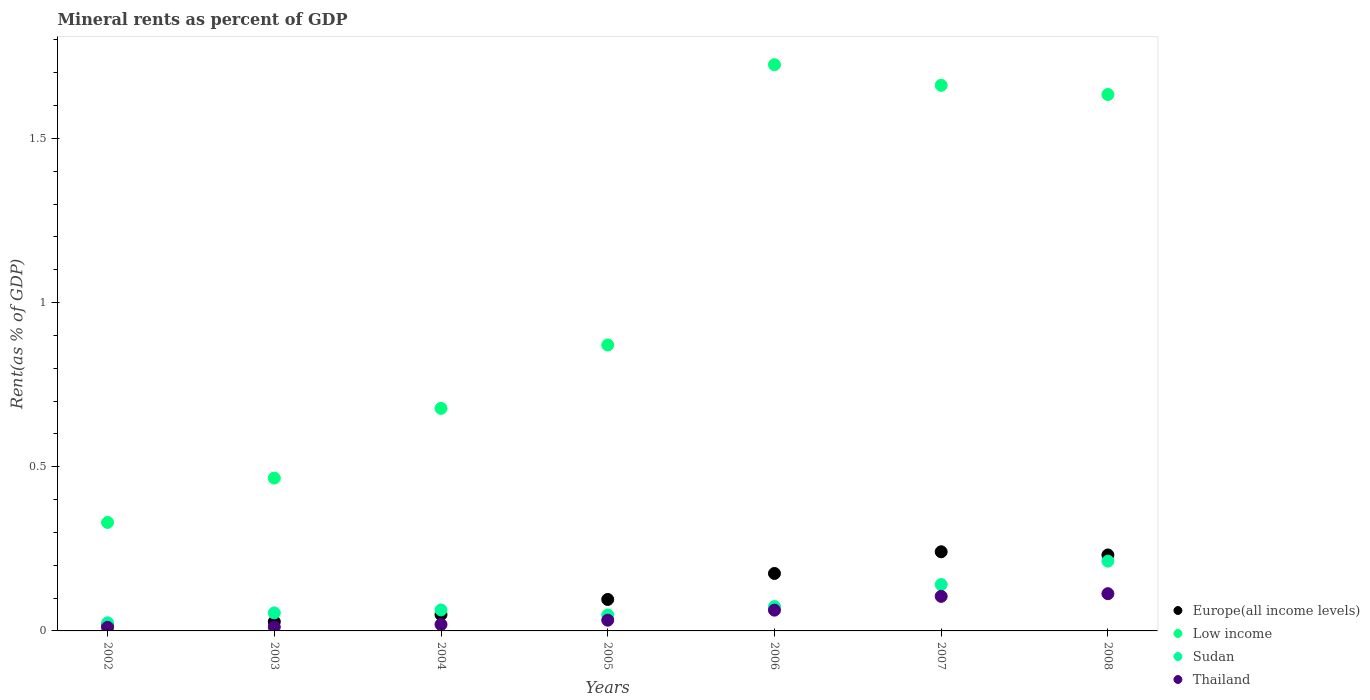How many different coloured dotlines are there?
Offer a very short reply. 4. Is the number of dotlines equal to the number of legend labels?
Keep it short and to the point. Yes. What is the mineral rent in Thailand in 2008?
Provide a succinct answer. 0.11. Across all years, what is the maximum mineral rent in Low income?
Give a very brief answer. 1.72. Across all years, what is the minimum mineral rent in Europe(all income levels)?
Ensure brevity in your answer.  0.02. In which year was the mineral rent in Thailand maximum?
Provide a short and direct response. 2008. In which year was the mineral rent in Europe(all income levels) minimum?
Your response must be concise. 2002. What is the total mineral rent in Europe(all income levels) in the graph?
Provide a short and direct response. 0.84. What is the difference between the mineral rent in Europe(all income levels) in 2003 and that in 2008?
Keep it short and to the point. -0.2. What is the difference between the mineral rent in Europe(all income levels) in 2006 and the mineral rent in Low income in 2004?
Provide a short and direct response. -0.5. What is the average mineral rent in Low income per year?
Keep it short and to the point. 1.05. In the year 2008, what is the difference between the mineral rent in Sudan and mineral rent in Thailand?
Offer a very short reply. 0.1. What is the ratio of the mineral rent in Thailand in 2007 to that in 2008?
Give a very brief answer. 0.93. Is the mineral rent in Sudan in 2003 less than that in 2004?
Ensure brevity in your answer.  Yes. Is the difference between the mineral rent in Sudan in 2003 and 2008 greater than the difference between the mineral rent in Thailand in 2003 and 2008?
Your response must be concise. No. What is the difference between the highest and the second highest mineral rent in Sudan?
Provide a short and direct response. 0.07. What is the difference between the highest and the lowest mineral rent in Low income?
Keep it short and to the point. 1.39. Is the sum of the mineral rent in Sudan in 2002 and 2006 greater than the maximum mineral rent in Europe(all income levels) across all years?
Ensure brevity in your answer.  No. Is it the case that in every year, the sum of the mineral rent in Low income and mineral rent in Europe(all income levels)  is greater than the sum of mineral rent in Thailand and mineral rent in Sudan?
Provide a short and direct response. Yes. Is it the case that in every year, the sum of the mineral rent in Low income and mineral rent in Europe(all income levels)  is greater than the mineral rent in Thailand?
Make the answer very short. Yes. Does the mineral rent in Low income monotonically increase over the years?
Give a very brief answer. No. How many dotlines are there?
Provide a short and direct response. 4. How many years are there in the graph?
Your answer should be very brief. 7. Where does the legend appear in the graph?
Ensure brevity in your answer.  Bottom right. How many legend labels are there?
Offer a very short reply. 4. How are the legend labels stacked?
Offer a very short reply. Vertical. What is the title of the graph?
Give a very brief answer. Mineral rents as percent of GDP. What is the label or title of the Y-axis?
Give a very brief answer. Rent(as % of GDP). What is the Rent(as % of GDP) of Europe(all income levels) in 2002?
Give a very brief answer. 0.02. What is the Rent(as % of GDP) in Low income in 2002?
Keep it short and to the point. 0.33. What is the Rent(as % of GDP) of Sudan in 2002?
Offer a terse response. 0.02. What is the Rent(as % of GDP) in Thailand in 2002?
Provide a short and direct response. 0.01. What is the Rent(as % of GDP) in Europe(all income levels) in 2003?
Give a very brief answer. 0.03. What is the Rent(as % of GDP) in Low income in 2003?
Ensure brevity in your answer.  0.47. What is the Rent(as % of GDP) of Sudan in 2003?
Offer a very short reply. 0.05. What is the Rent(as % of GDP) in Thailand in 2003?
Your response must be concise. 0.01. What is the Rent(as % of GDP) of Europe(all income levels) in 2004?
Offer a terse response. 0.05. What is the Rent(as % of GDP) of Low income in 2004?
Provide a short and direct response. 0.68. What is the Rent(as % of GDP) of Sudan in 2004?
Provide a short and direct response. 0.06. What is the Rent(as % of GDP) in Thailand in 2004?
Your answer should be compact. 0.02. What is the Rent(as % of GDP) in Europe(all income levels) in 2005?
Provide a succinct answer. 0.1. What is the Rent(as % of GDP) of Low income in 2005?
Offer a terse response. 0.87. What is the Rent(as % of GDP) of Sudan in 2005?
Provide a short and direct response. 0.05. What is the Rent(as % of GDP) of Thailand in 2005?
Keep it short and to the point. 0.03. What is the Rent(as % of GDP) in Europe(all income levels) in 2006?
Give a very brief answer. 0.18. What is the Rent(as % of GDP) of Low income in 2006?
Your answer should be compact. 1.72. What is the Rent(as % of GDP) of Sudan in 2006?
Your response must be concise. 0.07. What is the Rent(as % of GDP) of Thailand in 2006?
Your answer should be compact. 0.06. What is the Rent(as % of GDP) of Europe(all income levels) in 2007?
Offer a terse response. 0.24. What is the Rent(as % of GDP) of Low income in 2007?
Your answer should be compact. 1.66. What is the Rent(as % of GDP) of Sudan in 2007?
Make the answer very short. 0.14. What is the Rent(as % of GDP) of Thailand in 2007?
Make the answer very short. 0.11. What is the Rent(as % of GDP) in Europe(all income levels) in 2008?
Offer a terse response. 0.23. What is the Rent(as % of GDP) in Low income in 2008?
Make the answer very short. 1.63. What is the Rent(as % of GDP) in Sudan in 2008?
Keep it short and to the point. 0.21. What is the Rent(as % of GDP) in Thailand in 2008?
Make the answer very short. 0.11. Across all years, what is the maximum Rent(as % of GDP) of Europe(all income levels)?
Provide a short and direct response. 0.24. Across all years, what is the maximum Rent(as % of GDP) in Low income?
Give a very brief answer. 1.72. Across all years, what is the maximum Rent(as % of GDP) of Sudan?
Provide a short and direct response. 0.21. Across all years, what is the maximum Rent(as % of GDP) of Thailand?
Your answer should be very brief. 0.11. Across all years, what is the minimum Rent(as % of GDP) of Europe(all income levels)?
Provide a succinct answer. 0.02. Across all years, what is the minimum Rent(as % of GDP) of Low income?
Offer a terse response. 0.33. Across all years, what is the minimum Rent(as % of GDP) of Sudan?
Offer a terse response. 0.02. Across all years, what is the minimum Rent(as % of GDP) in Thailand?
Your answer should be very brief. 0.01. What is the total Rent(as % of GDP) in Europe(all income levels) in the graph?
Your answer should be compact. 0.84. What is the total Rent(as % of GDP) of Low income in the graph?
Provide a succinct answer. 7.36. What is the total Rent(as % of GDP) in Sudan in the graph?
Offer a very short reply. 0.62. What is the total Rent(as % of GDP) in Thailand in the graph?
Offer a terse response. 0.36. What is the difference between the Rent(as % of GDP) in Europe(all income levels) in 2002 and that in 2003?
Give a very brief answer. -0.01. What is the difference between the Rent(as % of GDP) of Low income in 2002 and that in 2003?
Offer a terse response. -0.14. What is the difference between the Rent(as % of GDP) in Sudan in 2002 and that in 2003?
Provide a short and direct response. -0.03. What is the difference between the Rent(as % of GDP) in Thailand in 2002 and that in 2003?
Your answer should be very brief. -0. What is the difference between the Rent(as % of GDP) of Europe(all income levels) in 2002 and that in 2004?
Offer a very short reply. -0.03. What is the difference between the Rent(as % of GDP) of Low income in 2002 and that in 2004?
Give a very brief answer. -0.35. What is the difference between the Rent(as % of GDP) of Sudan in 2002 and that in 2004?
Your answer should be very brief. -0.04. What is the difference between the Rent(as % of GDP) of Thailand in 2002 and that in 2004?
Offer a very short reply. -0.01. What is the difference between the Rent(as % of GDP) in Europe(all income levels) in 2002 and that in 2005?
Offer a terse response. -0.08. What is the difference between the Rent(as % of GDP) in Low income in 2002 and that in 2005?
Ensure brevity in your answer.  -0.54. What is the difference between the Rent(as % of GDP) of Sudan in 2002 and that in 2005?
Offer a very short reply. -0.02. What is the difference between the Rent(as % of GDP) in Thailand in 2002 and that in 2005?
Your answer should be very brief. -0.02. What is the difference between the Rent(as % of GDP) of Europe(all income levels) in 2002 and that in 2006?
Offer a very short reply. -0.16. What is the difference between the Rent(as % of GDP) of Low income in 2002 and that in 2006?
Provide a succinct answer. -1.39. What is the difference between the Rent(as % of GDP) in Sudan in 2002 and that in 2006?
Offer a very short reply. -0.05. What is the difference between the Rent(as % of GDP) in Thailand in 2002 and that in 2006?
Keep it short and to the point. -0.05. What is the difference between the Rent(as % of GDP) in Europe(all income levels) in 2002 and that in 2007?
Keep it short and to the point. -0.22. What is the difference between the Rent(as % of GDP) of Low income in 2002 and that in 2007?
Offer a very short reply. -1.33. What is the difference between the Rent(as % of GDP) of Sudan in 2002 and that in 2007?
Provide a succinct answer. -0.12. What is the difference between the Rent(as % of GDP) of Thailand in 2002 and that in 2007?
Ensure brevity in your answer.  -0.09. What is the difference between the Rent(as % of GDP) in Europe(all income levels) in 2002 and that in 2008?
Your answer should be compact. -0.21. What is the difference between the Rent(as % of GDP) of Low income in 2002 and that in 2008?
Offer a very short reply. -1.3. What is the difference between the Rent(as % of GDP) in Sudan in 2002 and that in 2008?
Your answer should be compact. -0.19. What is the difference between the Rent(as % of GDP) of Thailand in 2002 and that in 2008?
Provide a succinct answer. -0.1. What is the difference between the Rent(as % of GDP) in Europe(all income levels) in 2003 and that in 2004?
Keep it short and to the point. -0.02. What is the difference between the Rent(as % of GDP) of Low income in 2003 and that in 2004?
Offer a very short reply. -0.21. What is the difference between the Rent(as % of GDP) in Sudan in 2003 and that in 2004?
Provide a succinct answer. -0.01. What is the difference between the Rent(as % of GDP) of Thailand in 2003 and that in 2004?
Ensure brevity in your answer.  -0.01. What is the difference between the Rent(as % of GDP) in Europe(all income levels) in 2003 and that in 2005?
Your answer should be compact. -0.07. What is the difference between the Rent(as % of GDP) in Low income in 2003 and that in 2005?
Provide a succinct answer. -0.41. What is the difference between the Rent(as % of GDP) of Sudan in 2003 and that in 2005?
Ensure brevity in your answer.  0.01. What is the difference between the Rent(as % of GDP) in Thailand in 2003 and that in 2005?
Your response must be concise. -0.02. What is the difference between the Rent(as % of GDP) of Europe(all income levels) in 2003 and that in 2006?
Give a very brief answer. -0.15. What is the difference between the Rent(as % of GDP) of Low income in 2003 and that in 2006?
Keep it short and to the point. -1.26. What is the difference between the Rent(as % of GDP) in Sudan in 2003 and that in 2006?
Your answer should be compact. -0.02. What is the difference between the Rent(as % of GDP) of Thailand in 2003 and that in 2006?
Offer a very short reply. -0.05. What is the difference between the Rent(as % of GDP) in Europe(all income levels) in 2003 and that in 2007?
Offer a very short reply. -0.21. What is the difference between the Rent(as % of GDP) in Low income in 2003 and that in 2007?
Provide a succinct answer. -1.2. What is the difference between the Rent(as % of GDP) in Sudan in 2003 and that in 2007?
Ensure brevity in your answer.  -0.09. What is the difference between the Rent(as % of GDP) of Thailand in 2003 and that in 2007?
Provide a succinct answer. -0.09. What is the difference between the Rent(as % of GDP) of Europe(all income levels) in 2003 and that in 2008?
Provide a succinct answer. -0.2. What is the difference between the Rent(as % of GDP) of Low income in 2003 and that in 2008?
Offer a terse response. -1.17. What is the difference between the Rent(as % of GDP) in Sudan in 2003 and that in 2008?
Keep it short and to the point. -0.16. What is the difference between the Rent(as % of GDP) in Thailand in 2003 and that in 2008?
Provide a succinct answer. -0.1. What is the difference between the Rent(as % of GDP) in Europe(all income levels) in 2004 and that in 2005?
Your answer should be very brief. -0.05. What is the difference between the Rent(as % of GDP) of Low income in 2004 and that in 2005?
Your answer should be compact. -0.19. What is the difference between the Rent(as % of GDP) in Sudan in 2004 and that in 2005?
Provide a short and direct response. 0.02. What is the difference between the Rent(as % of GDP) of Thailand in 2004 and that in 2005?
Offer a terse response. -0.01. What is the difference between the Rent(as % of GDP) of Europe(all income levels) in 2004 and that in 2006?
Your response must be concise. -0.13. What is the difference between the Rent(as % of GDP) of Low income in 2004 and that in 2006?
Make the answer very short. -1.05. What is the difference between the Rent(as % of GDP) in Sudan in 2004 and that in 2006?
Your response must be concise. -0.01. What is the difference between the Rent(as % of GDP) in Thailand in 2004 and that in 2006?
Keep it short and to the point. -0.04. What is the difference between the Rent(as % of GDP) in Europe(all income levels) in 2004 and that in 2007?
Provide a succinct answer. -0.19. What is the difference between the Rent(as % of GDP) of Low income in 2004 and that in 2007?
Ensure brevity in your answer.  -0.98. What is the difference between the Rent(as % of GDP) in Sudan in 2004 and that in 2007?
Give a very brief answer. -0.08. What is the difference between the Rent(as % of GDP) of Thailand in 2004 and that in 2007?
Keep it short and to the point. -0.09. What is the difference between the Rent(as % of GDP) in Europe(all income levels) in 2004 and that in 2008?
Offer a very short reply. -0.18. What is the difference between the Rent(as % of GDP) of Low income in 2004 and that in 2008?
Offer a very short reply. -0.96. What is the difference between the Rent(as % of GDP) in Sudan in 2004 and that in 2008?
Offer a terse response. -0.15. What is the difference between the Rent(as % of GDP) of Thailand in 2004 and that in 2008?
Offer a terse response. -0.09. What is the difference between the Rent(as % of GDP) of Europe(all income levels) in 2005 and that in 2006?
Give a very brief answer. -0.08. What is the difference between the Rent(as % of GDP) in Low income in 2005 and that in 2006?
Your response must be concise. -0.85. What is the difference between the Rent(as % of GDP) in Sudan in 2005 and that in 2006?
Your answer should be very brief. -0.03. What is the difference between the Rent(as % of GDP) of Thailand in 2005 and that in 2006?
Keep it short and to the point. -0.03. What is the difference between the Rent(as % of GDP) in Europe(all income levels) in 2005 and that in 2007?
Your answer should be compact. -0.15. What is the difference between the Rent(as % of GDP) of Low income in 2005 and that in 2007?
Offer a very short reply. -0.79. What is the difference between the Rent(as % of GDP) of Sudan in 2005 and that in 2007?
Your response must be concise. -0.09. What is the difference between the Rent(as % of GDP) of Thailand in 2005 and that in 2007?
Make the answer very short. -0.07. What is the difference between the Rent(as % of GDP) of Europe(all income levels) in 2005 and that in 2008?
Offer a terse response. -0.14. What is the difference between the Rent(as % of GDP) of Low income in 2005 and that in 2008?
Provide a short and direct response. -0.76. What is the difference between the Rent(as % of GDP) of Sudan in 2005 and that in 2008?
Provide a short and direct response. -0.16. What is the difference between the Rent(as % of GDP) of Thailand in 2005 and that in 2008?
Your response must be concise. -0.08. What is the difference between the Rent(as % of GDP) of Europe(all income levels) in 2006 and that in 2007?
Your response must be concise. -0.07. What is the difference between the Rent(as % of GDP) of Low income in 2006 and that in 2007?
Provide a short and direct response. 0.06. What is the difference between the Rent(as % of GDP) in Sudan in 2006 and that in 2007?
Provide a succinct answer. -0.07. What is the difference between the Rent(as % of GDP) of Thailand in 2006 and that in 2007?
Offer a terse response. -0.04. What is the difference between the Rent(as % of GDP) in Europe(all income levels) in 2006 and that in 2008?
Ensure brevity in your answer.  -0.06. What is the difference between the Rent(as % of GDP) of Low income in 2006 and that in 2008?
Offer a very short reply. 0.09. What is the difference between the Rent(as % of GDP) of Sudan in 2006 and that in 2008?
Offer a very short reply. -0.14. What is the difference between the Rent(as % of GDP) of Thailand in 2006 and that in 2008?
Your response must be concise. -0.05. What is the difference between the Rent(as % of GDP) in Europe(all income levels) in 2007 and that in 2008?
Give a very brief answer. 0.01. What is the difference between the Rent(as % of GDP) of Low income in 2007 and that in 2008?
Make the answer very short. 0.03. What is the difference between the Rent(as % of GDP) in Sudan in 2007 and that in 2008?
Offer a terse response. -0.07. What is the difference between the Rent(as % of GDP) of Thailand in 2007 and that in 2008?
Offer a terse response. -0.01. What is the difference between the Rent(as % of GDP) of Europe(all income levels) in 2002 and the Rent(as % of GDP) of Low income in 2003?
Provide a short and direct response. -0.45. What is the difference between the Rent(as % of GDP) in Europe(all income levels) in 2002 and the Rent(as % of GDP) in Sudan in 2003?
Make the answer very short. -0.04. What is the difference between the Rent(as % of GDP) of Europe(all income levels) in 2002 and the Rent(as % of GDP) of Thailand in 2003?
Offer a terse response. 0.01. What is the difference between the Rent(as % of GDP) of Low income in 2002 and the Rent(as % of GDP) of Sudan in 2003?
Provide a short and direct response. 0.28. What is the difference between the Rent(as % of GDP) in Low income in 2002 and the Rent(as % of GDP) in Thailand in 2003?
Give a very brief answer. 0.32. What is the difference between the Rent(as % of GDP) in Sudan in 2002 and the Rent(as % of GDP) in Thailand in 2003?
Offer a very short reply. 0.01. What is the difference between the Rent(as % of GDP) of Europe(all income levels) in 2002 and the Rent(as % of GDP) of Low income in 2004?
Offer a very short reply. -0.66. What is the difference between the Rent(as % of GDP) of Europe(all income levels) in 2002 and the Rent(as % of GDP) of Sudan in 2004?
Your answer should be compact. -0.05. What is the difference between the Rent(as % of GDP) of Europe(all income levels) in 2002 and the Rent(as % of GDP) of Thailand in 2004?
Offer a terse response. -0. What is the difference between the Rent(as % of GDP) in Low income in 2002 and the Rent(as % of GDP) in Sudan in 2004?
Your answer should be compact. 0.27. What is the difference between the Rent(as % of GDP) of Low income in 2002 and the Rent(as % of GDP) of Thailand in 2004?
Keep it short and to the point. 0.31. What is the difference between the Rent(as % of GDP) in Sudan in 2002 and the Rent(as % of GDP) in Thailand in 2004?
Offer a very short reply. 0.01. What is the difference between the Rent(as % of GDP) in Europe(all income levels) in 2002 and the Rent(as % of GDP) in Low income in 2005?
Provide a succinct answer. -0.85. What is the difference between the Rent(as % of GDP) of Europe(all income levels) in 2002 and the Rent(as % of GDP) of Sudan in 2005?
Your answer should be compact. -0.03. What is the difference between the Rent(as % of GDP) in Europe(all income levels) in 2002 and the Rent(as % of GDP) in Thailand in 2005?
Keep it short and to the point. -0.01. What is the difference between the Rent(as % of GDP) in Low income in 2002 and the Rent(as % of GDP) in Sudan in 2005?
Keep it short and to the point. 0.28. What is the difference between the Rent(as % of GDP) of Low income in 2002 and the Rent(as % of GDP) of Thailand in 2005?
Give a very brief answer. 0.3. What is the difference between the Rent(as % of GDP) of Sudan in 2002 and the Rent(as % of GDP) of Thailand in 2005?
Ensure brevity in your answer.  -0.01. What is the difference between the Rent(as % of GDP) of Europe(all income levels) in 2002 and the Rent(as % of GDP) of Low income in 2006?
Your answer should be compact. -1.71. What is the difference between the Rent(as % of GDP) in Europe(all income levels) in 2002 and the Rent(as % of GDP) in Sudan in 2006?
Your answer should be very brief. -0.06. What is the difference between the Rent(as % of GDP) in Europe(all income levels) in 2002 and the Rent(as % of GDP) in Thailand in 2006?
Offer a very short reply. -0.05. What is the difference between the Rent(as % of GDP) of Low income in 2002 and the Rent(as % of GDP) of Sudan in 2006?
Your response must be concise. 0.26. What is the difference between the Rent(as % of GDP) of Low income in 2002 and the Rent(as % of GDP) of Thailand in 2006?
Provide a short and direct response. 0.27. What is the difference between the Rent(as % of GDP) in Sudan in 2002 and the Rent(as % of GDP) in Thailand in 2006?
Your answer should be compact. -0.04. What is the difference between the Rent(as % of GDP) of Europe(all income levels) in 2002 and the Rent(as % of GDP) of Low income in 2007?
Keep it short and to the point. -1.64. What is the difference between the Rent(as % of GDP) of Europe(all income levels) in 2002 and the Rent(as % of GDP) of Sudan in 2007?
Offer a terse response. -0.12. What is the difference between the Rent(as % of GDP) of Europe(all income levels) in 2002 and the Rent(as % of GDP) of Thailand in 2007?
Offer a very short reply. -0.09. What is the difference between the Rent(as % of GDP) in Low income in 2002 and the Rent(as % of GDP) in Sudan in 2007?
Offer a terse response. 0.19. What is the difference between the Rent(as % of GDP) in Low income in 2002 and the Rent(as % of GDP) in Thailand in 2007?
Provide a short and direct response. 0.23. What is the difference between the Rent(as % of GDP) in Sudan in 2002 and the Rent(as % of GDP) in Thailand in 2007?
Offer a very short reply. -0.08. What is the difference between the Rent(as % of GDP) of Europe(all income levels) in 2002 and the Rent(as % of GDP) of Low income in 2008?
Ensure brevity in your answer.  -1.62. What is the difference between the Rent(as % of GDP) of Europe(all income levels) in 2002 and the Rent(as % of GDP) of Sudan in 2008?
Give a very brief answer. -0.19. What is the difference between the Rent(as % of GDP) in Europe(all income levels) in 2002 and the Rent(as % of GDP) in Thailand in 2008?
Ensure brevity in your answer.  -0.1. What is the difference between the Rent(as % of GDP) in Low income in 2002 and the Rent(as % of GDP) in Sudan in 2008?
Ensure brevity in your answer.  0.12. What is the difference between the Rent(as % of GDP) in Low income in 2002 and the Rent(as % of GDP) in Thailand in 2008?
Give a very brief answer. 0.22. What is the difference between the Rent(as % of GDP) in Sudan in 2002 and the Rent(as % of GDP) in Thailand in 2008?
Keep it short and to the point. -0.09. What is the difference between the Rent(as % of GDP) in Europe(all income levels) in 2003 and the Rent(as % of GDP) in Low income in 2004?
Provide a succinct answer. -0.65. What is the difference between the Rent(as % of GDP) in Europe(all income levels) in 2003 and the Rent(as % of GDP) in Sudan in 2004?
Provide a short and direct response. -0.04. What is the difference between the Rent(as % of GDP) of Europe(all income levels) in 2003 and the Rent(as % of GDP) of Thailand in 2004?
Your answer should be very brief. 0.01. What is the difference between the Rent(as % of GDP) of Low income in 2003 and the Rent(as % of GDP) of Sudan in 2004?
Offer a very short reply. 0.4. What is the difference between the Rent(as % of GDP) of Low income in 2003 and the Rent(as % of GDP) of Thailand in 2004?
Your answer should be very brief. 0.45. What is the difference between the Rent(as % of GDP) of Sudan in 2003 and the Rent(as % of GDP) of Thailand in 2004?
Keep it short and to the point. 0.04. What is the difference between the Rent(as % of GDP) in Europe(all income levels) in 2003 and the Rent(as % of GDP) in Low income in 2005?
Your answer should be compact. -0.84. What is the difference between the Rent(as % of GDP) of Europe(all income levels) in 2003 and the Rent(as % of GDP) of Sudan in 2005?
Ensure brevity in your answer.  -0.02. What is the difference between the Rent(as % of GDP) of Europe(all income levels) in 2003 and the Rent(as % of GDP) of Thailand in 2005?
Your response must be concise. -0. What is the difference between the Rent(as % of GDP) of Low income in 2003 and the Rent(as % of GDP) of Sudan in 2005?
Make the answer very short. 0.42. What is the difference between the Rent(as % of GDP) in Low income in 2003 and the Rent(as % of GDP) in Thailand in 2005?
Keep it short and to the point. 0.43. What is the difference between the Rent(as % of GDP) in Sudan in 2003 and the Rent(as % of GDP) in Thailand in 2005?
Provide a short and direct response. 0.02. What is the difference between the Rent(as % of GDP) of Europe(all income levels) in 2003 and the Rent(as % of GDP) of Low income in 2006?
Your answer should be compact. -1.7. What is the difference between the Rent(as % of GDP) of Europe(all income levels) in 2003 and the Rent(as % of GDP) of Sudan in 2006?
Provide a short and direct response. -0.05. What is the difference between the Rent(as % of GDP) of Europe(all income levels) in 2003 and the Rent(as % of GDP) of Thailand in 2006?
Provide a succinct answer. -0.04. What is the difference between the Rent(as % of GDP) of Low income in 2003 and the Rent(as % of GDP) of Sudan in 2006?
Give a very brief answer. 0.39. What is the difference between the Rent(as % of GDP) of Low income in 2003 and the Rent(as % of GDP) of Thailand in 2006?
Provide a succinct answer. 0.4. What is the difference between the Rent(as % of GDP) in Sudan in 2003 and the Rent(as % of GDP) in Thailand in 2006?
Offer a terse response. -0.01. What is the difference between the Rent(as % of GDP) in Europe(all income levels) in 2003 and the Rent(as % of GDP) in Low income in 2007?
Make the answer very short. -1.63. What is the difference between the Rent(as % of GDP) of Europe(all income levels) in 2003 and the Rent(as % of GDP) of Sudan in 2007?
Your answer should be compact. -0.11. What is the difference between the Rent(as % of GDP) of Europe(all income levels) in 2003 and the Rent(as % of GDP) of Thailand in 2007?
Provide a short and direct response. -0.08. What is the difference between the Rent(as % of GDP) in Low income in 2003 and the Rent(as % of GDP) in Sudan in 2007?
Offer a very short reply. 0.32. What is the difference between the Rent(as % of GDP) in Low income in 2003 and the Rent(as % of GDP) in Thailand in 2007?
Make the answer very short. 0.36. What is the difference between the Rent(as % of GDP) of Sudan in 2003 and the Rent(as % of GDP) of Thailand in 2007?
Your answer should be very brief. -0.05. What is the difference between the Rent(as % of GDP) in Europe(all income levels) in 2003 and the Rent(as % of GDP) in Low income in 2008?
Your response must be concise. -1.61. What is the difference between the Rent(as % of GDP) in Europe(all income levels) in 2003 and the Rent(as % of GDP) in Sudan in 2008?
Ensure brevity in your answer.  -0.18. What is the difference between the Rent(as % of GDP) in Europe(all income levels) in 2003 and the Rent(as % of GDP) in Thailand in 2008?
Your response must be concise. -0.09. What is the difference between the Rent(as % of GDP) in Low income in 2003 and the Rent(as % of GDP) in Sudan in 2008?
Offer a very short reply. 0.25. What is the difference between the Rent(as % of GDP) in Low income in 2003 and the Rent(as % of GDP) in Thailand in 2008?
Give a very brief answer. 0.35. What is the difference between the Rent(as % of GDP) in Sudan in 2003 and the Rent(as % of GDP) in Thailand in 2008?
Provide a succinct answer. -0.06. What is the difference between the Rent(as % of GDP) in Europe(all income levels) in 2004 and the Rent(as % of GDP) in Low income in 2005?
Your answer should be compact. -0.82. What is the difference between the Rent(as % of GDP) in Europe(all income levels) in 2004 and the Rent(as % of GDP) in Sudan in 2005?
Provide a succinct answer. 0. What is the difference between the Rent(as % of GDP) of Europe(all income levels) in 2004 and the Rent(as % of GDP) of Thailand in 2005?
Provide a short and direct response. 0.02. What is the difference between the Rent(as % of GDP) in Low income in 2004 and the Rent(as % of GDP) in Sudan in 2005?
Provide a short and direct response. 0.63. What is the difference between the Rent(as % of GDP) in Low income in 2004 and the Rent(as % of GDP) in Thailand in 2005?
Your response must be concise. 0.65. What is the difference between the Rent(as % of GDP) in Sudan in 2004 and the Rent(as % of GDP) in Thailand in 2005?
Make the answer very short. 0.03. What is the difference between the Rent(as % of GDP) of Europe(all income levels) in 2004 and the Rent(as % of GDP) of Low income in 2006?
Ensure brevity in your answer.  -1.67. What is the difference between the Rent(as % of GDP) in Europe(all income levels) in 2004 and the Rent(as % of GDP) in Sudan in 2006?
Make the answer very short. -0.02. What is the difference between the Rent(as % of GDP) in Europe(all income levels) in 2004 and the Rent(as % of GDP) in Thailand in 2006?
Make the answer very short. -0.01. What is the difference between the Rent(as % of GDP) of Low income in 2004 and the Rent(as % of GDP) of Sudan in 2006?
Your answer should be very brief. 0.6. What is the difference between the Rent(as % of GDP) of Low income in 2004 and the Rent(as % of GDP) of Thailand in 2006?
Keep it short and to the point. 0.61. What is the difference between the Rent(as % of GDP) of Sudan in 2004 and the Rent(as % of GDP) of Thailand in 2006?
Provide a succinct answer. 0. What is the difference between the Rent(as % of GDP) in Europe(all income levels) in 2004 and the Rent(as % of GDP) in Low income in 2007?
Ensure brevity in your answer.  -1.61. What is the difference between the Rent(as % of GDP) in Europe(all income levels) in 2004 and the Rent(as % of GDP) in Sudan in 2007?
Offer a very short reply. -0.09. What is the difference between the Rent(as % of GDP) of Europe(all income levels) in 2004 and the Rent(as % of GDP) of Thailand in 2007?
Your answer should be very brief. -0.06. What is the difference between the Rent(as % of GDP) of Low income in 2004 and the Rent(as % of GDP) of Sudan in 2007?
Provide a short and direct response. 0.54. What is the difference between the Rent(as % of GDP) in Low income in 2004 and the Rent(as % of GDP) in Thailand in 2007?
Give a very brief answer. 0.57. What is the difference between the Rent(as % of GDP) of Sudan in 2004 and the Rent(as % of GDP) of Thailand in 2007?
Provide a short and direct response. -0.04. What is the difference between the Rent(as % of GDP) of Europe(all income levels) in 2004 and the Rent(as % of GDP) of Low income in 2008?
Your response must be concise. -1.58. What is the difference between the Rent(as % of GDP) in Europe(all income levels) in 2004 and the Rent(as % of GDP) in Sudan in 2008?
Provide a short and direct response. -0.16. What is the difference between the Rent(as % of GDP) of Europe(all income levels) in 2004 and the Rent(as % of GDP) of Thailand in 2008?
Provide a short and direct response. -0.06. What is the difference between the Rent(as % of GDP) of Low income in 2004 and the Rent(as % of GDP) of Sudan in 2008?
Make the answer very short. 0.47. What is the difference between the Rent(as % of GDP) in Low income in 2004 and the Rent(as % of GDP) in Thailand in 2008?
Your answer should be very brief. 0.56. What is the difference between the Rent(as % of GDP) in Sudan in 2004 and the Rent(as % of GDP) in Thailand in 2008?
Make the answer very short. -0.05. What is the difference between the Rent(as % of GDP) in Europe(all income levels) in 2005 and the Rent(as % of GDP) in Low income in 2006?
Your answer should be compact. -1.63. What is the difference between the Rent(as % of GDP) of Europe(all income levels) in 2005 and the Rent(as % of GDP) of Sudan in 2006?
Give a very brief answer. 0.02. What is the difference between the Rent(as % of GDP) of Europe(all income levels) in 2005 and the Rent(as % of GDP) of Thailand in 2006?
Offer a very short reply. 0.03. What is the difference between the Rent(as % of GDP) in Low income in 2005 and the Rent(as % of GDP) in Sudan in 2006?
Keep it short and to the point. 0.8. What is the difference between the Rent(as % of GDP) in Low income in 2005 and the Rent(as % of GDP) in Thailand in 2006?
Provide a short and direct response. 0.81. What is the difference between the Rent(as % of GDP) in Sudan in 2005 and the Rent(as % of GDP) in Thailand in 2006?
Make the answer very short. -0.01. What is the difference between the Rent(as % of GDP) of Europe(all income levels) in 2005 and the Rent(as % of GDP) of Low income in 2007?
Make the answer very short. -1.57. What is the difference between the Rent(as % of GDP) in Europe(all income levels) in 2005 and the Rent(as % of GDP) in Sudan in 2007?
Your response must be concise. -0.05. What is the difference between the Rent(as % of GDP) in Europe(all income levels) in 2005 and the Rent(as % of GDP) in Thailand in 2007?
Offer a terse response. -0.01. What is the difference between the Rent(as % of GDP) in Low income in 2005 and the Rent(as % of GDP) in Sudan in 2007?
Provide a short and direct response. 0.73. What is the difference between the Rent(as % of GDP) of Low income in 2005 and the Rent(as % of GDP) of Thailand in 2007?
Your answer should be compact. 0.77. What is the difference between the Rent(as % of GDP) of Sudan in 2005 and the Rent(as % of GDP) of Thailand in 2007?
Your response must be concise. -0.06. What is the difference between the Rent(as % of GDP) of Europe(all income levels) in 2005 and the Rent(as % of GDP) of Low income in 2008?
Your response must be concise. -1.54. What is the difference between the Rent(as % of GDP) in Europe(all income levels) in 2005 and the Rent(as % of GDP) in Sudan in 2008?
Provide a short and direct response. -0.12. What is the difference between the Rent(as % of GDP) of Europe(all income levels) in 2005 and the Rent(as % of GDP) of Thailand in 2008?
Offer a terse response. -0.02. What is the difference between the Rent(as % of GDP) in Low income in 2005 and the Rent(as % of GDP) in Sudan in 2008?
Your answer should be compact. 0.66. What is the difference between the Rent(as % of GDP) of Low income in 2005 and the Rent(as % of GDP) of Thailand in 2008?
Ensure brevity in your answer.  0.76. What is the difference between the Rent(as % of GDP) of Sudan in 2005 and the Rent(as % of GDP) of Thailand in 2008?
Your answer should be very brief. -0.06. What is the difference between the Rent(as % of GDP) of Europe(all income levels) in 2006 and the Rent(as % of GDP) of Low income in 2007?
Your response must be concise. -1.49. What is the difference between the Rent(as % of GDP) of Europe(all income levels) in 2006 and the Rent(as % of GDP) of Sudan in 2007?
Your answer should be compact. 0.03. What is the difference between the Rent(as % of GDP) in Europe(all income levels) in 2006 and the Rent(as % of GDP) in Thailand in 2007?
Your answer should be compact. 0.07. What is the difference between the Rent(as % of GDP) of Low income in 2006 and the Rent(as % of GDP) of Sudan in 2007?
Give a very brief answer. 1.58. What is the difference between the Rent(as % of GDP) in Low income in 2006 and the Rent(as % of GDP) in Thailand in 2007?
Your answer should be compact. 1.62. What is the difference between the Rent(as % of GDP) of Sudan in 2006 and the Rent(as % of GDP) of Thailand in 2007?
Ensure brevity in your answer.  -0.03. What is the difference between the Rent(as % of GDP) in Europe(all income levels) in 2006 and the Rent(as % of GDP) in Low income in 2008?
Offer a very short reply. -1.46. What is the difference between the Rent(as % of GDP) in Europe(all income levels) in 2006 and the Rent(as % of GDP) in Sudan in 2008?
Keep it short and to the point. -0.04. What is the difference between the Rent(as % of GDP) in Europe(all income levels) in 2006 and the Rent(as % of GDP) in Thailand in 2008?
Provide a succinct answer. 0.06. What is the difference between the Rent(as % of GDP) in Low income in 2006 and the Rent(as % of GDP) in Sudan in 2008?
Your answer should be compact. 1.51. What is the difference between the Rent(as % of GDP) of Low income in 2006 and the Rent(as % of GDP) of Thailand in 2008?
Give a very brief answer. 1.61. What is the difference between the Rent(as % of GDP) of Sudan in 2006 and the Rent(as % of GDP) of Thailand in 2008?
Keep it short and to the point. -0.04. What is the difference between the Rent(as % of GDP) of Europe(all income levels) in 2007 and the Rent(as % of GDP) of Low income in 2008?
Give a very brief answer. -1.39. What is the difference between the Rent(as % of GDP) of Europe(all income levels) in 2007 and the Rent(as % of GDP) of Sudan in 2008?
Offer a terse response. 0.03. What is the difference between the Rent(as % of GDP) in Europe(all income levels) in 2007 and the Rent(as % of GDP) in Thailand in 2008?
Make the answer very short. 0.13. What is the difference between the Rent(as % of GDP) of Low income in 2007 and the Rent(as % of GDP) of Sudan in 2008?
Provide a succinct answer. 1.45. What is the difference between the Rent(as % of GDP) of Low income in 2007 and the Rent(as % of GDP) of Thailand in 2008?
Offer a very short reply. 1.55. What is the difference between the Rent(as % of GDP) of Sudan in 2007 and the Rent(as % of GDP) of Thailand in 2008?
Keep it short and to the point. 0.03. What is the average Rent(as % of GDP) in Europe(all income levels) per year?
Give a very brief answer. 0.12. What is the average Rent(as % of GDP) in Low income per year?
Keep it short and to the point. 1.05. What is the average Rent(as % of GDP) in Sudan per year?
Offer a very short reply. 0.09. What is the average Rent(as % of GDP) of Thailand per year?
Make the answer very short. 0.05. In the year 2002, what is the difference between the Rent(as % of GDP) in Europe(all income levels) and Rent(as % of GDP) in Low income?
Your response must be concise. -0.31. In the year 2002, what is the difference between the Rent(as % of GDP) of Europe(all income levels) and Rent(as % of GDP) of Sudan?
Make the answer very short. -0.01. In the year 2002, what is the difference between the Rent(as % of GDP) of Europe(all income levels) and Rent(as % of GDP) of Thailand?
Your response must be concise. 0.01. In the year 2002, what is the difference between the Rent(as % of GDP) in Low income and Rent(as % of GDP) in Sudan?
Your answer should be compact. 0.31. In the year 2002, what is the difference between the Rent(as % of GDP) of Low income and Rent(as % of GDP) of Thailand?
Provide a succinct answer. 0.32. In the year 2002, what is the difference between the Rent(as % of GDP) in Sudan and Rent(as % of GDP) in Thailand?
Offer a terse response. 0.01. In the year 2003, what is the difference between the Rent(as % of GDP) in Europe(all income levels) and Rent(as % of GDP) in Low income?
Your answer should be compact. -0.44. In the year 2003, what is the difference between the Rent(as % of GDP) of Europe(all income levels) and Rent(as % of GDP) of Sudan?
Ensure brevity in your answer.  -0.03. In the year 2003, what is the difference between the Rent(as % of GDP) of Europe(all income levels) and Rent(as % of GDP) of Thailand?
Offer a terse response. 0.02. In the year 2003, what is the difference between the Rent(as % of GDP) in Low income and Rent(as % of GDP) in Sudan?
Make the answer very short. 0.41. In the year 2003, what is the difference between the Rent(as % of GDP) in Low income and Rent(as % of GDP) in Thailand?
Your response must be concise. 0.45. In the year 2003, what is the difference between the Rent(as % of GDP) of Sudan and Rent(as % of GDP) of Thailand?
Offer a very short reply. 0.04. In the year 2004, what is the difference between the Rent(as % of GDP) in Europe(all income levels) and Rent(as % of GDP) in Low income?
Give a very brief answer. -0.63. In the year 2004, what is the difference between the Rent(as % of GDP) in Europe(all income levels) and Rent(as % of GDP) in Sudan?
Give a very brief answer. -0.01. In the year 2004, what is the difference between the Rent(as % of GDP) of Europe(all income levels) and Rent(as % of GDP) of Thailand?
Your answer should be compact. 0.03. In the year 2004, what is the difference between the Rent(as % of GDP) of Low income and Rent(as % of GDP) of Sudan?
Your answer should be very brief. 0.61. In the year 2004, what is the difference between the Rent(as % of GDP) in Low income and Rent(as % of GDP) in Thailand?
Your answer should be compact. 0.66. In the year 2004, what is the difference between the Rent(as % of GDP) of Sudan and Rent(as % of GDP) of Thailand?
Provide a short and direct response. 0.04. In the year 2005, what is the difference between the Rent(as % of GDP) in Europe(all income levels) and Rent(as % of GDP) in Low income?
Offer a terse response. -0.78. In the year 2005, what is the difference between the Rent(as % of GDP) of Europe(all income levels) and Rent(as % of GDP) of Sudan?
Keep it short and to the point. 0.05. In the year 2005, what is the difference between the Rent(as % of GDP) of Europe(all income levels) and Rent(as % of GDP) of Thailand?
Provide a succinct answer. 0.06. In the year 2005, what is the difference between the Rent(as % of GDP) in Low income and Rent(as % of GDP) in Sudan?
Give a very brief answer. 0.82. In the year 2005, what is the difference between the Rent(as % of GDP) of Low income and Rent(as % of GDP) of Thailand?
Your answer should be compact. 0.84. In the year 2005, what is the difference between the Rent(as % of GDP) in Sudan and Rent(as % of GDP) in Thailand?
Provide a succinct answer. 0.02. In the year 2006, what is the difference between the Rent(as % of GDP) in Europe(all income levels) and Rent(as % of GDP) in Low income?
Offer a very short reply. -1.55. In the year 2006, what is the difference between the Rent(as % of GDP) in Europe(all income levels) and Rent(as % of GDP) in Sudan?
Your response must be concise. 0.1. In the year 2006, what is the difference between the Rent(as % of GDP) in Europe(all income levels) and Rent(as % of GDP) in Thailand?
Provide a succinct answer. 0.11. In the year 2006, what is the difference between the Rent(as % of GDP) in Low income and Rent(as % of GDP) in Sudan?
Your answer should be compact. 1.65. In the year 2006, what is the difference between the Rent(as % of GDP) in Low income and Rent(as % of GDP) in Thailand?
Offer a very short reply. 1.66. In the year 2006, what is the difference between the Rent(as % of GDP) of Sudan and Rent(as % of GDP) of Thailand?
Offer a terse response. 0.01. In the year 2007, what is the difference between the Rent(as % of GDP) in Europe(all income levels) and Rent(as % of GDP) in Low income?
Your response must be concise. -1.42. In the year 2007, what is the difference between the Rent(as % of GDP) in Europe(all income levels) and Rent(as % of GDP) in Sudan?
Provide a short and direct response. 0.1. In the year 2007, what is the difference between the Rent(as % of GDP) of Europe(all income levels) and Rent(as % of GDP) of Thailand?
Ensure brevity in your answer.  0.14. In the year 2007, what is the difference between the Rent(as % of GDP) in Low income and Rent(as % of GDP) in Sudan?
Offer a terse response. 1.52. In the year 2007, what is the difference between the Rent(as % of GDP) in Low income and Rent(as % of GDP) in Thailand?
Make the answer very short. 1.56. In the year 2007, what is the difference between the Rent(as % of GDP) in Sudan and Rent(as % of GDP) in Thailand?
Your answer should be compact. 0.04. In the year 2008, what is the difference between the Rent(as % of GDP) in Europe(all income levels) and Rent(as % of GDP) in Low income?
Provide a short and direct response. -1.4. In the year 2008, what is the difference between the Rent(as % of GDP) of Europe(all income levels) and Rent(as % of GDP) of Sudan?
Give a very brief answer. 0.02. In the year 2008, what is the difference between the Rent(as % of GDP) in Europe(all income levels) and Rent(as % of GDP) in Thailand?
Your answer should be compact. 0.12. In the year 2008, what is the difference between the Rent(as % of GDP) of Low income and Rent(as % of GDP) of Sudan?
Provide a succinct answer. 1.42. In the year 2008, what is the difference between the Rent(as % of GDP) of Low income and Rent(as % of GDP) of Thailand?
Provide a succinct answer. 1.52. In the year 2008, what is the difference between the Rent(as % of GDP) of Sudan and Rent(as % of GDP) of Thailand?
Give a very brief answer. 0.1. What is the ratio of the Rent(as % of GDP) of Europe(all income levels) in 2002 to that in 2003?
Your answer should be very brief. 0.64. What is the ratio of the Rent(as % of GDP) of Low income in 2002 to that in 2003?
Ensure brevity in your answer.  0.71. What is the ratio of the Rent(as % of GDP) of Sudan in 2002 to that in 2003?
Give a very brief answer. 0.45. What is the ratio of the Rent(as % of GDP) of Thailand in 2002 to that in 2003?
Ensure brevity in your answer.  0.9. What is the ratio of the Rent(as % of GDP) of Europe(all income levels) in 2002 to that in 2004?
Ensure brevity in your answer.  0.36. What is the ratio of the Rent(as % of GDP) of Low income in 2002 to that in 2004?
Provide a succinct answer. 0.49. What is the ratio of the Rent(as % of GDP) of Sudan in 2002 to that in 2004?
Your response must be concise. 0.39. What is the ratio of the Rent(as % of GDP) of Thailand in 2002 to that in 2004?
Your answer should be very brief. 0.56. What is the ratio of the Rent(as % of GDP) in Europe(all income levels) in 2002 to that in 2005?
Ensure brevity in your answer.  0.19. What is the ratio of the Rent(as % of GDP) of Low income in 2002 to that in 2005?
Offer a very short reply. 0.38. What is the ratio of the Rent(as % of GDP) in Sudan in 2002 to that in 2005?
Ensure brevity in your answer.  0.51. What is the ratio of the Rent(as % of GDP) of Thailand in 2002 to that in 2005?
Ensure brevity in your answer.  0.33. What is the ratio of the Rent(as % of GDP) in Europe(all income levels) in 2002 to that in 2006?
Your response must be concise. 0.1. What is the ratio of the Rent(as % of GDP) of Low income in 2002 to that in 2006?
Offer a terse response. 0.19. What is the ratio of the Rent(as % of GDP) of Sudan in 2002 to that in 2006?
Keep it short and to the point. 0.33. What is the ratio of the Rent(as % of GDP) of Thailand in 2002 to that in 2006?
Your answer should be compact. 0.17. What is the ratio of the Rent(as % of GDP) of Europe(all income levels) in 2002 to that in 2007?
Give a very brief answer. 0.07. What is the ratio of the Rent(as % of GDP) in Low income in 2002 to that in 2007?
Provide a short and direct response. 0.2. What is the ratio of the Rent(as % of GDP) in Sudan in 2002 to that in 2007?
Keep it short and to the point. 0.17. What is the ratio of the Rent(as % of GDP) in Thailand in 2002 to that in 2007?
Keep it short and to the point. 0.1. What is the ratio of the Rent(as % of GDP) of Europe(all income levels) in 2002 to that in 2008?
Your answer should be very brief. 0.08. What is the ratio of the Rent(as % of GDP) in Low income in 2002 to that in 2008?
Offer a very short reply. 0.2. What is the ratio of the Rent(as % of GDP) of Sudan in 2002 to that in 2008?
Offer a terse response. 0.12. What is the ratio of the Rent(as % of GDP) of Thailand in 2002 to that in 2008?
Ensure brevity in your answer.  0.1. What is the ratio of the Rent(as % of GDP) of Europe(all income levels) in 2003 to that in 2004?
Offer a very short reply. 0.56. What is the ratio of the Rent(as % of GDP) in Low income in 2003 to that in 2004?
Ensure brevity in your answer.  0.69. What is the ratio of the Rent(as % of GDP) of Sudan in 2003 to that in 2004?
Offer a terse response. 0.86. What is the ratio of the Rent(as % of GDP) in Thailand in 2003 to that in 2004?
Keep it short and to the point. 0.62. What is the ratio of the Rent(as % of GDP) in Europe(all income levels) in 2003 to that in 2005?
Your answer should be very brief. 0.29. What is the ratio of the Rent(as % of GDP) in Low income in 2003 to that in 2005?
Provide a succinct answer. 0.53. What is the ratio of the Rent(as % of GDP) in Sudan in 2003 to that in 2005?
Keep it short and to the point. 1.13. What is the ratio of the Rent(as % of GDP) of Thailand in 2003 to that in 2005?
Provide a short and direct response. 0.37. What is the ratio of the Rent(as % of GDP) of Europe(all income levels) in 2003 to that in 2006?
Your response must be concise. 0.16. What is the ratio of the Rent(as % of GDP) in Low income in 2003 to that in 2006?
Ensure brevity in your answer.  0.27. What is the ratio of the Rent(as % of GDP) of Sudan in 2003 to that in 2006?
Your answer should be very brief. 0.74. What is the ratio of the Rent(as % of GDP) of Thailand in 2003 to that in 2006?
Provide a succinct answer. 0.19. What is the ratio of the Rent(as % of GDP) of Europe(all income levels) in 2003 to that in 2007?
Offer a terse response. 0.12. What is the ratio of the Rent(as % of GDP) of Low income in 2003 to that in 2007?
Make the answer very short. 0.28. What is the ratio of the Rent(as % of GDP) of Sudan in 2003 to that in 2007?
Keep it short and to the point. 0.39. What is the ratio of the Rent(as % of GDP) of Thailand in 2003 to that in 2007?
Give a very brief answer. 0.11. What is the ratio of the Rent(as % of GDP) of Europe(all income levels) in 2003 to that in 2008?
Ensure brevity in your answer.  0.12. What is the ratio of the Rent(as % of GDP) in Low income in 2003 to that in 2008?
Offer a very short reply. 0.28. What is the ratio of the Rent(as % of GDP) in Sudan in 2003 to that in 2008?
Provide a short and direct response. 0.26. What is the ratio of the Rent(as % of GDP) of Thailand in 2003 to that in 2008?
Provide a succinct answer. 0.11. What is the ratio of the Rent(as % of GDP) of Europe(all income levels) in 2004 to that in 2005?
Provide a succinct answer. 0.52. What is the ratio of the Rent(as % of GDP) of Low income in 2004 to that in 2005?
Provide a succinct answer. 0.78. What is the ratio of the Rent(as % of GDP) in Sudan in 2004 to that in 2005?
Your answer should be compact. 1.31. What is the ratio of the Rent(as % of GDP) of Thailand in 2004 to that in 2005?
Keep it short and to the point. 0.6. What is the ratio of the Rent(as % of GDP) in Europe(all income levels) in 2004 to that in 2006?
Offer a very short reply. 0.28. What is the ratio of the Rent(as % of GDP) in Low income in 2004 to that in 2006?
Make the answer very short. 0.39. What is the ratio of the Rent(as % of GDP) of Sudan in 2004 to that in 2006?
Your response must be concise. 0.86. What is the ratio of the Rent(as % of GDP) in Thailand in 2004 to that in 2006?
Make the answer very short. 0.31. What is the ratio of the Rent(as % of GDP) of Europe(all income levels) in 2004 to that in 2007?
Your response must be concise. 0.21. What is the ratio of the Rent(as % of GDP) in Low income in 2004 to that in 2007?
Provide a succinct answer. 0.41. What is the ratio of the Rent(as % of GDP) in Sudan in 2004 to that in 2007?
Your response must be concise. 0.45. What is the ratio of the Rent(as % of GDP) of Thailand in 2004 to that in 2007?
Ensure brevity in your answer.  0.19. What is the ratio of the Rent(as % of GDP) in Europe(all income levels) in 2004 to that in 2008?
Make the answer very short. 0.22. What is the ratio of the Rent(as % of GDP) in Low income in 2004 to that in 2008?
Your response must be concise. 0.41. What is the ratio of the Rent(as % of GDP) in Sudan in 2004 to that in 2008?
Provide a short and direct response. 0.3. What is the ratio of the Rent(as % of GDP) of Thailand in 2004 to that in 2008?
Provide a short and direct response. 0.17. What is the ratio of the Rent(as % of GDP) in Europe(all income levels) in 2005 to that in 2006?
Your response must be concise. 0.55. What is the ratio of the Rent(as % of GDP) of Low income in 2005 to that in 2006?
Offer a very short reply. 0.51. What is the ratio of the Rent(as % of GDP) in Sudan in 2005 to that in 2006?
Give a very brief answer. 0.66. What is the ratio of the Rent(as % of GDP) of Thailand in 2005 to that in 2006?
Offer a terse response. 0.52. What is the ratio of the Rent(as % of GDP) of Europe(all income levels) in 2005 to that in 2007?
Offer a very short reply. 0.4. What is the ratio of the Rent(as % of GDP) of Low income in 2005 to that in 2007?
Your response must be concise. 0.52. What is the ratio of the Rent(as % of GDP) in Sudan in 2005 to that in 2007?
Provide a succinct answer. 0.34. What is the ratio of the Rent(as % of GDP) in Thailand in 2005 to that in 2007?
Your answer should be very brief. 0.31. What is the ratio of the Rent(as % of GDP) of Europe(all income levels) in 2005 to that in 2008?
Provide a succinct answer. 0.41. What is the ratio of the Rent(as % of GDP) in Low income in 2005 to that in 2008?
Give a very brief answer. 0.53. What is the ratio of the Rent(as % of GDP) of Sudan in 2005 to that in 2008?
Provide a succinct answer. 0.23. What is the ratio of the Rent(as % of GDP) of Thailand in 2005 to that in 2008?
Your answer should be very brief. 0.29. What is the ratio of the Rent(as % of GDP) in Europe(all income levels) in 2006 to that in 2007?
Provide a succinct answer. 0.73. What is the ratio of the Rent(as % of GDP) of Low income in 2006 to that in 2007?
Provide a succinct answer. 1.04. What is the ratio of the Rent(as % of GDP) in Sudan in 2006 to that in 2007?
Your response must be concise. 0.53. What is the ratio of the Rent(as % of GDP) in Thailand in 2006 to that in 2007?
Keep it short and to the point. 0.6. What is the ratio of the Rent(as % of GDP) of Europe(all income levels) in 2006 to that in 2008?
Your answer should be compact. 0.76. What is the ratio of the Rent(as % of GDP) of Low income in 2006 to that in 2008?
Provide a succinct answer. 1.06. What is the ratio of the Rent(as % of GDP) in Sudan in 2006 to that in 2008?
Make the answer very short. 0.35. What is the ratio of the Rent(as % of GDP) of Thailand in 2006 to that in 2008?
Keep it short and to the point. 0.56. What is the ratio of the Rent(as % of GDP) in Europe(all income levels) in 2007 to that in 2008?
Provide a short and direct response. 1.04. What is the ratio of the Rent(as % of GDP) of Low income in 2007 to that in 2008?
Offer a terse response. 1.02. What is the ratio of the Rent(as % of GDP) of Sudan in 2007 to that in 2008?
Offer a very short reply. 0.66. What is the ratio of the Rent(as % of GDP) in Thailand in 2007 to that in 2008?
Provide a short and direct response. 0.93. What is the difference between the highest and the second highest Rent(as % of GDP) of Europe(all income levels)?
Offer a terse response. 0.01. What is the difference between the highest and the second highest Rent(as % of GDP) in Low income?
Offer a very short reply. 0.06. What is the difference between the highest and the second highest Rent(as % of GDP) of Sudan?
Make the answer very short. 0.07. What is the difference between the highest and the second highest Rent(as % of GDP) of Thailand?
Offer a terse response. 0.01. What is the difference between the highest and the lowest Rent(as % of GDP) of Europe(all income levels)?
Provide a succinct answer. 0.22. What is the difference between the highest and the lowest Rent(as % of GDP) in Low income?
Offer a terse response. 1.39. What is the difference between the highest and the lowest Rent(as % of GDP) of Sudan?
Keep it short and to the point. 0.19. What is the difference between the highest and the lowest Rent(as % of GDP) of Thailand?
Provide a short and direct response. 0.1. 